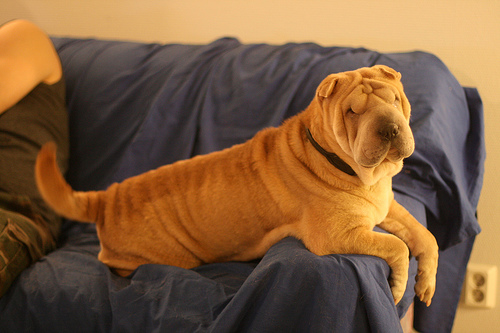How many dogs are there? There is one dog in the image. It's a Shar Pei, easily recognizable by its deep wrinkles and a sandy-colored coat. 